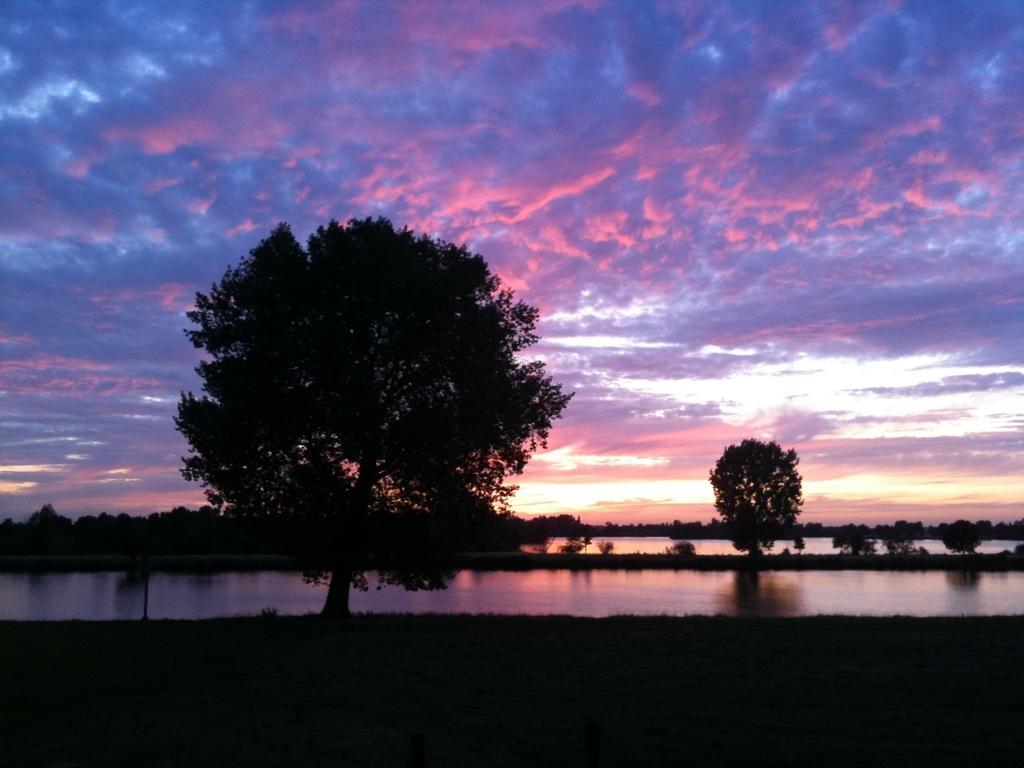Describe this image in one or two sentences. In this image we can see few trees, water and the sky in the background. 